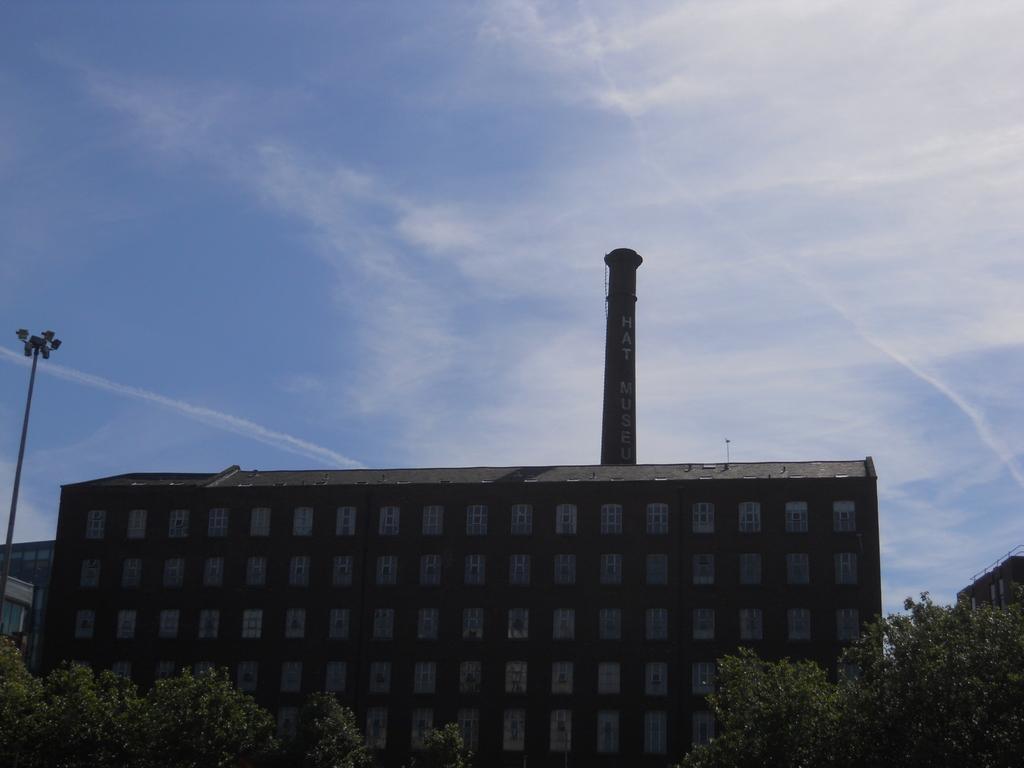Describe this image in one or two sentences. In this image I can see the sky and building , in front of the building I can see trees , on the left side left side I can see a pole. 